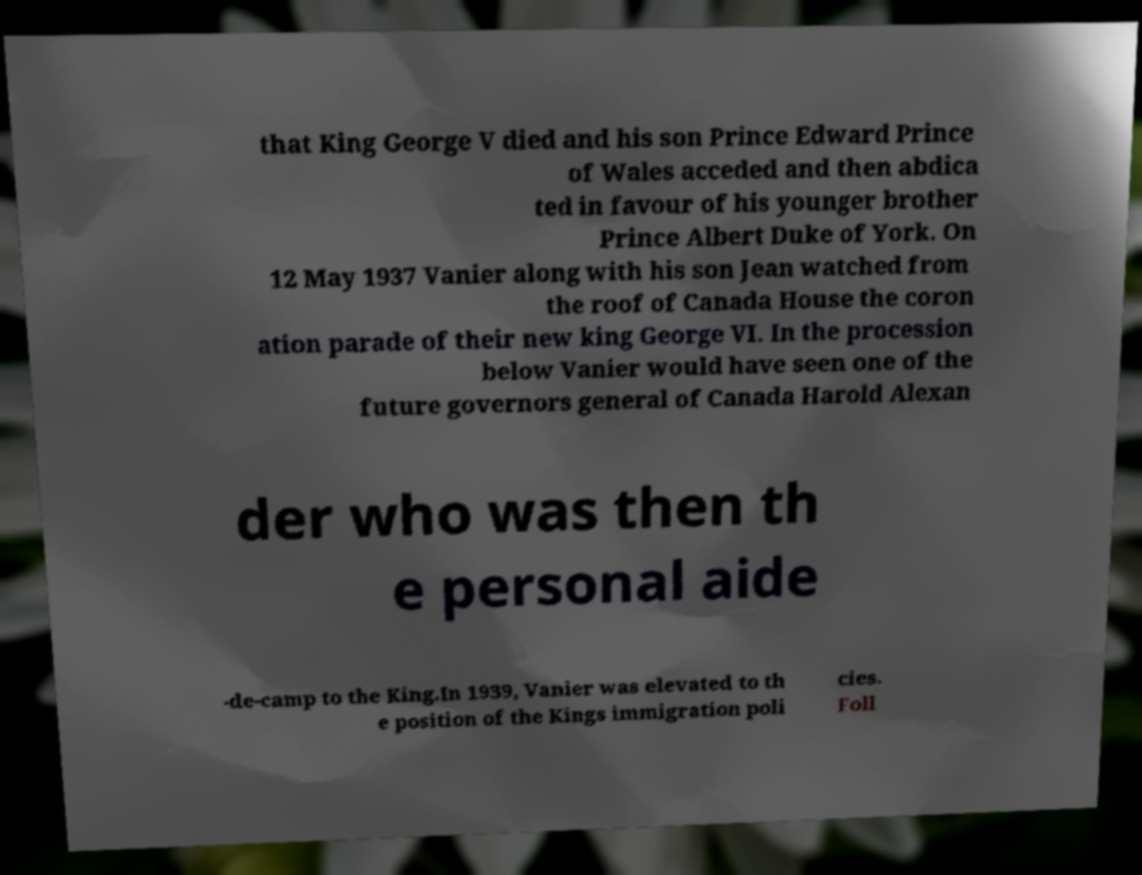Can you accurately transcribe the text from the provided image for me? that King George V died and his son Prince Edward Prince of Wales acceded and then abdica ted in favour of his younger brother Prince Albert Duke of York. On 12 May 1937 Vanier along with his son Jean watched from the roof of Canada House the coron ation parade of their new king George VI. In the procession below Vanier would have seen one of the future governors general of Canada Harold Alexan der who was then th e personal aide -de-camp to the King.In 1939, Vanier was elevated to th e position of the Kings immigration poli cies. Foll 